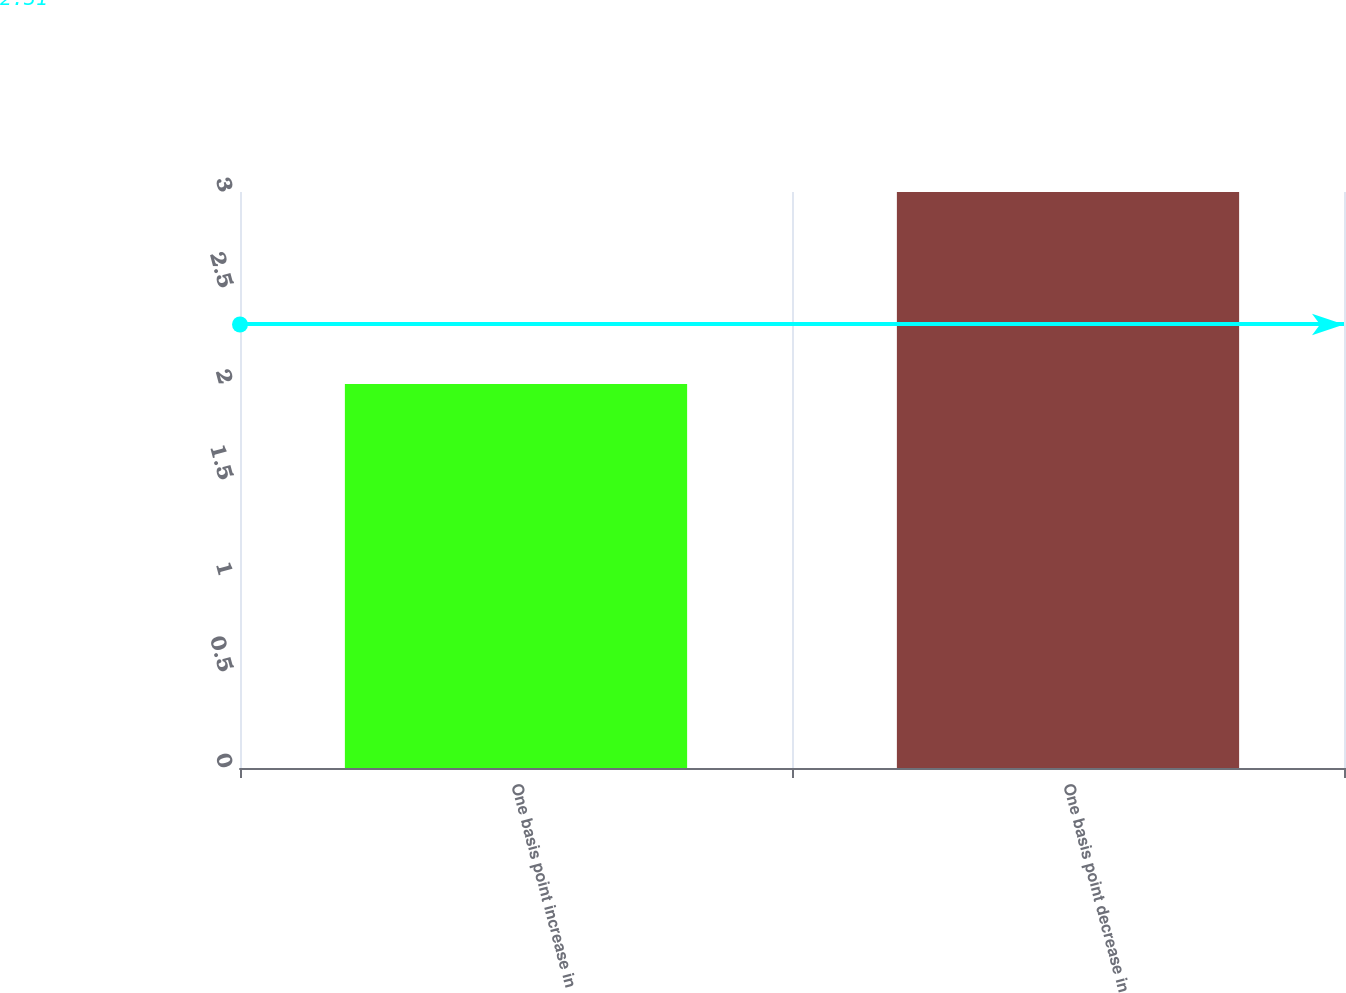<chart> <loc_0><loc_0><loc_500><loc_500><bar_chart><fcel>One basis point increase in<fcel>One basis point decrease in<nl><fcel>2<fcel>3<nl></chart> 